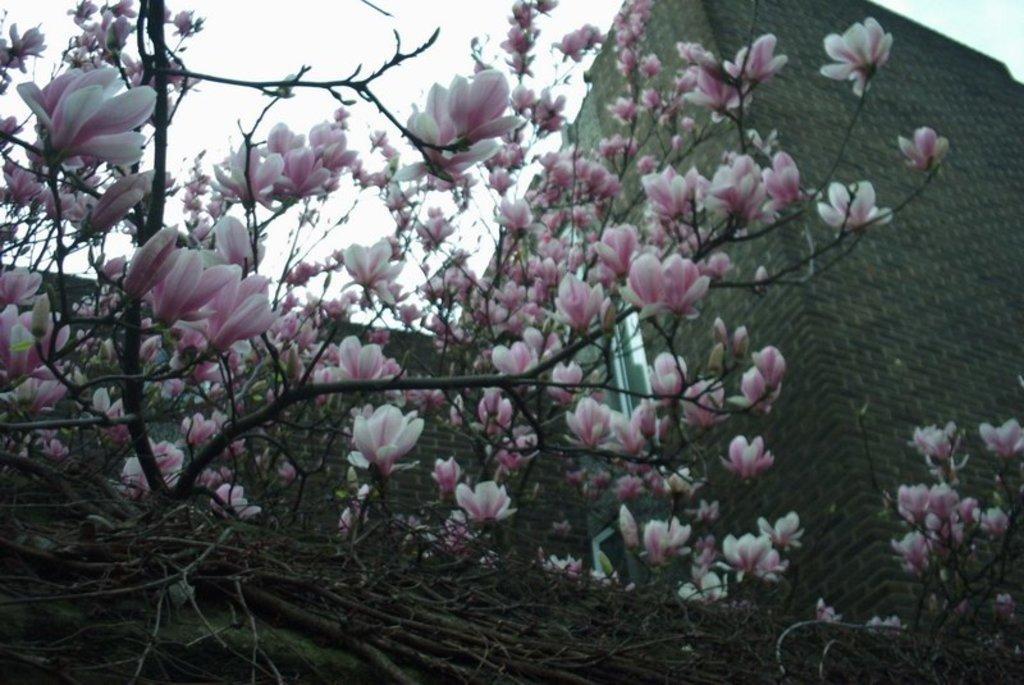Can you describe this image briefly? In this image there are flowers on a tree, in the background of the image there is a building. 